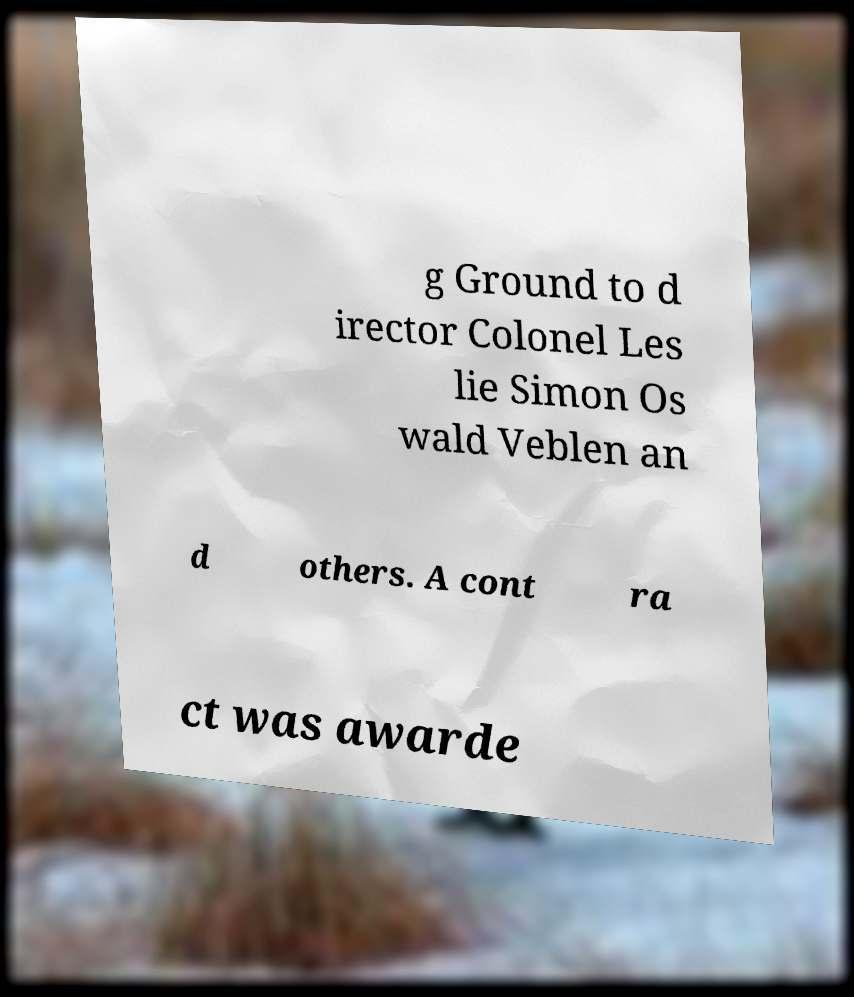Can you accurately transcribe the text from the provided image for me? g Ground to d irector Colonel Les lie Simon Os wald Veblen an d others. A cont ra ct was awarde 